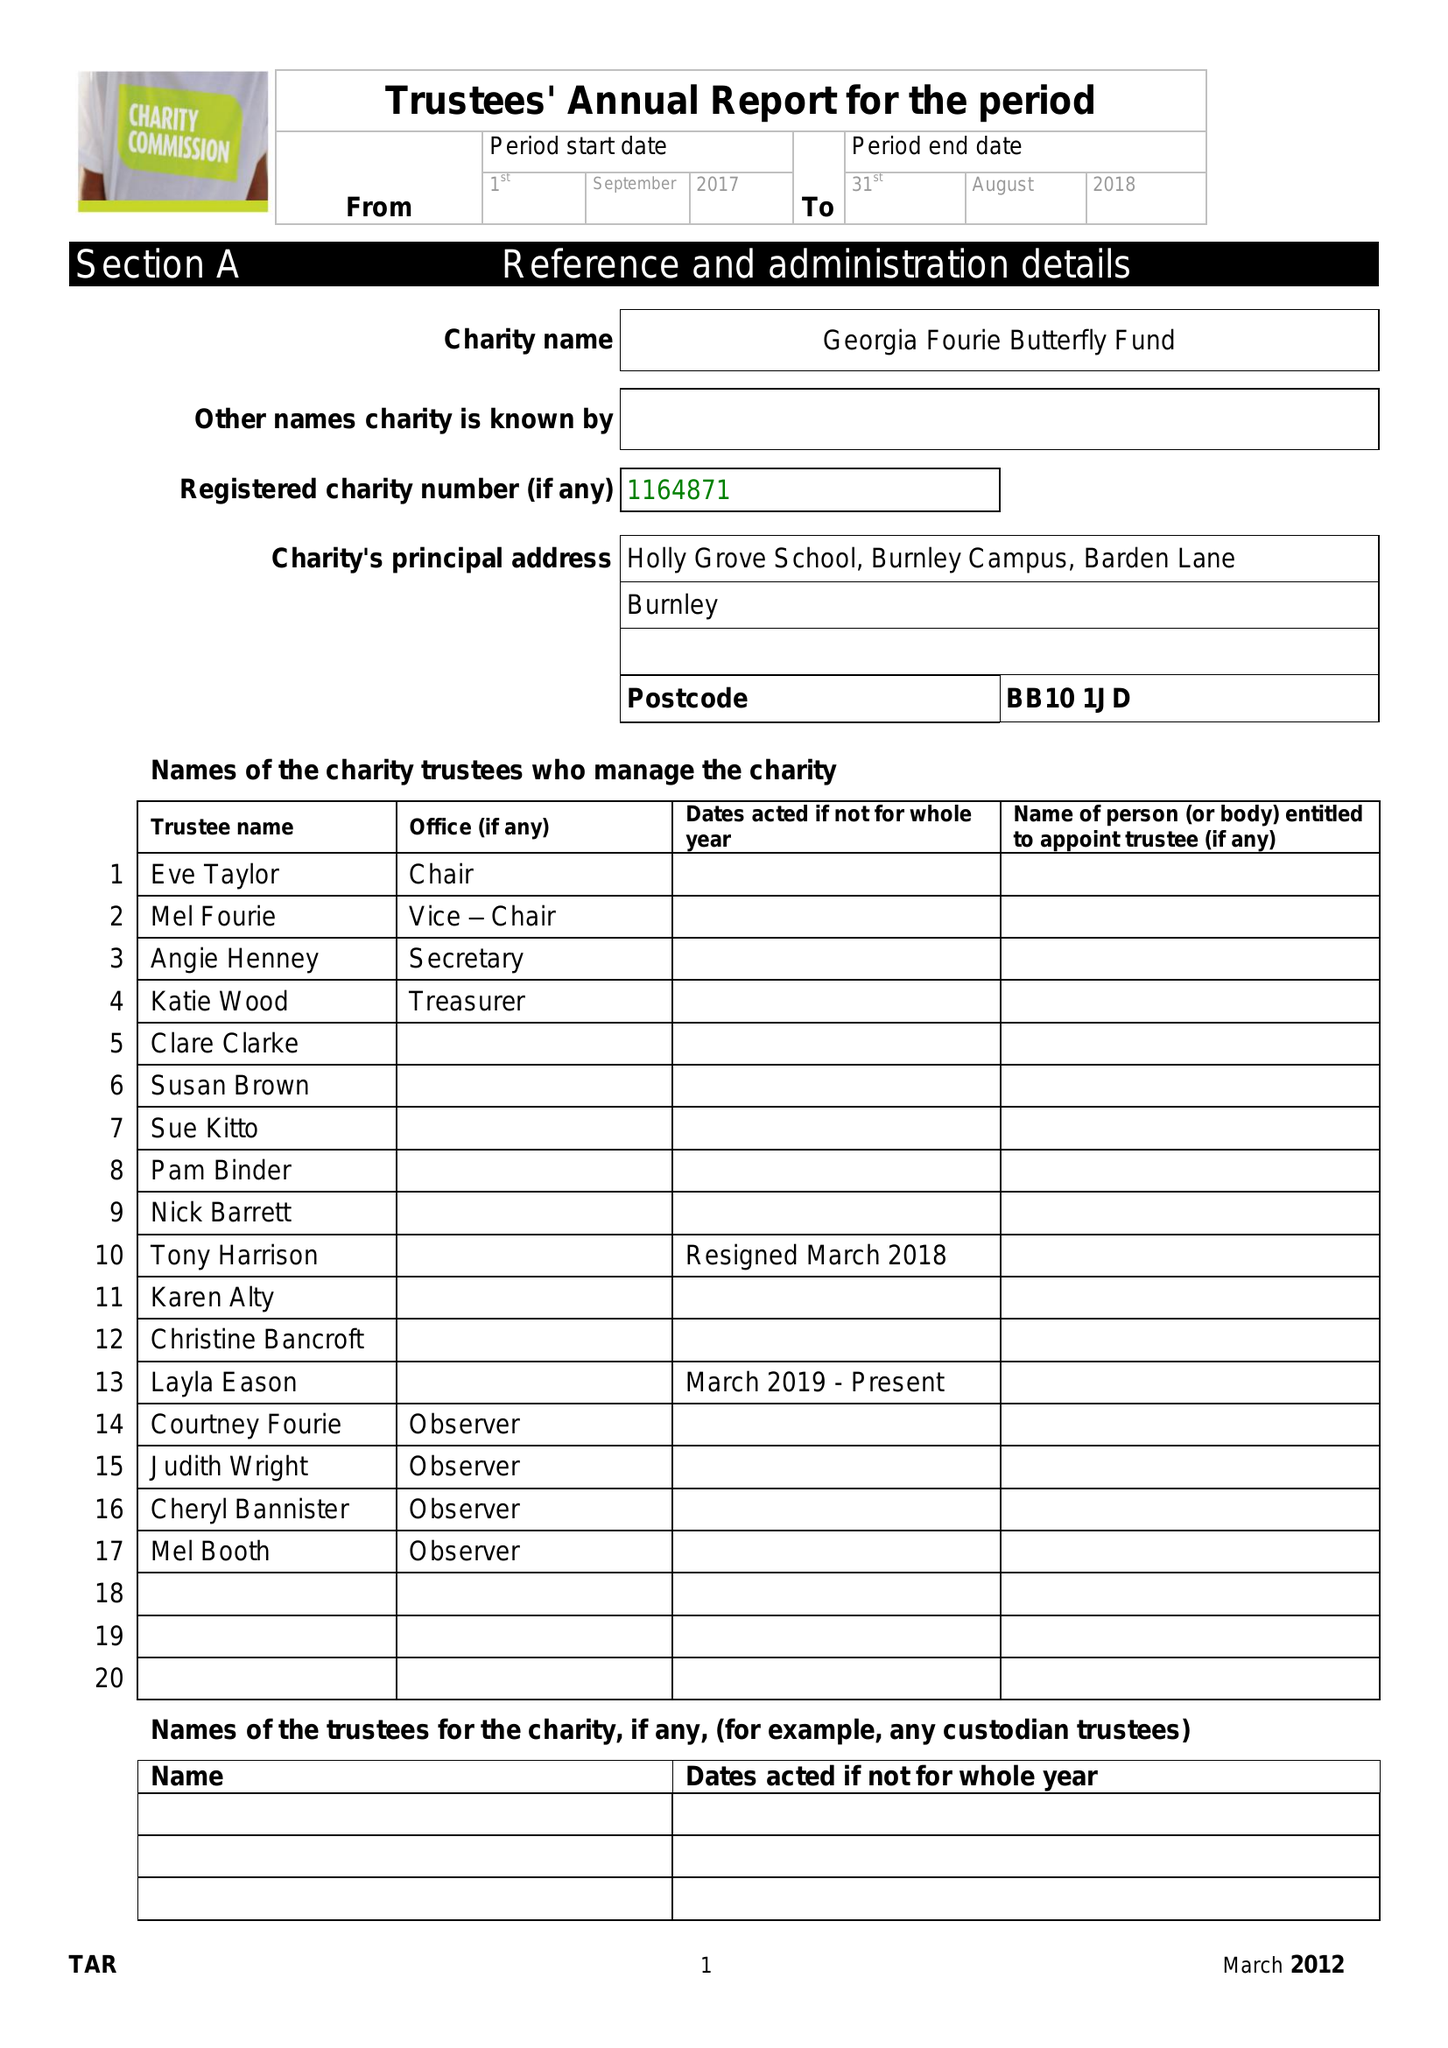What is the value for the charity_number?
Answer the question using a single word or phrase. 1164871 